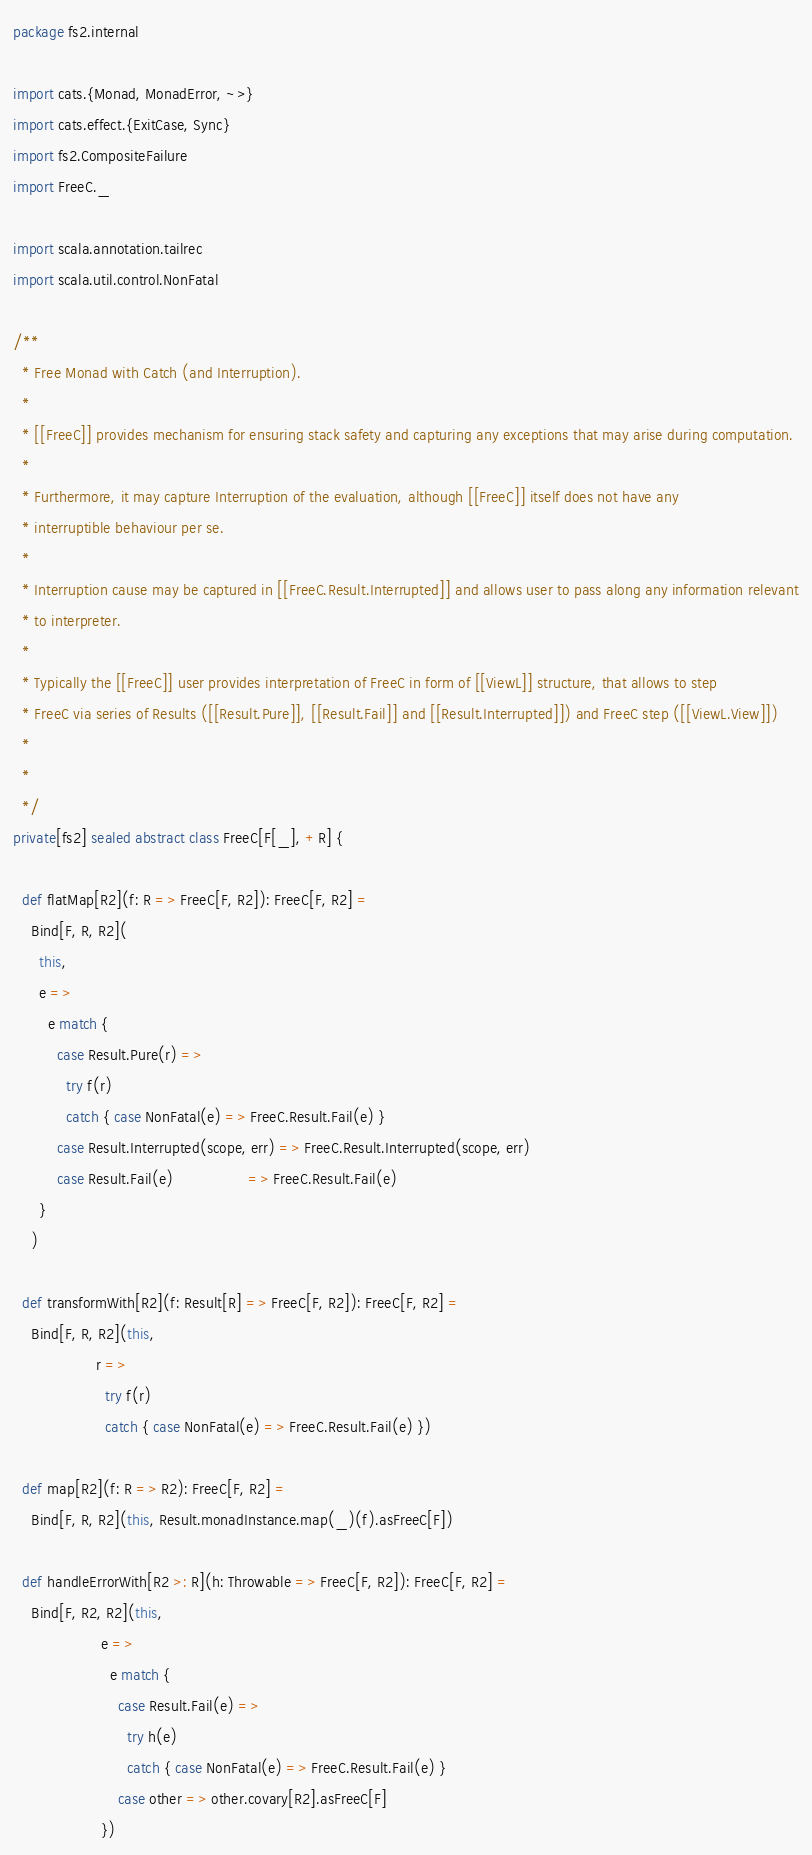<code> <loc_0><loc_0><loc_500><loc_500><_Scala_>package fs2.internal

import cats.{Monad, MonadError, ~>}
import cats.effect.{ExitCase, Sync}
import fs2.CompositeFailure
import FreeC._

import scala.annotation.tailrec
import scala.util.control.NonFatal

/**
  * Free Monad with Catch (and Interruption).
  *
  * [[FreeC]] provides mechanism for ensuring stack safety and capturing any exceptions that may arise during computation.
  *
  * Furthermore, it may capture Interruption of the evaluation, although [[FreeC]] itself does not have any
  * interruptible behaviour per se.
  *
  * Interruption cause may be captured in [[FreeC.Result.Interrupted]] and allows user to pass along any information relevant
  * to interpreter.
  *
  * Typically the [[FreeC]] user provides interpretation of FreeC in form of [[ViewL]] structure, that allows to step
  * FreeC via series of Results ([[Result.Pure]], [[Result.Fail]] and [[Result.Interrupted]]) and FreeC step ([[ViewL.View]])
  *
  *
  */
private[fs2] sealed abstract class FreeC[F[_], +R] {

  def flatMap[R2](f: R => FreeC[F, R2]): FreeC[F, R2] =
    Bind[F, R, R2](
      this,
      e =>
        e match {
          case Result.Pure(r) =>
            try f(r)
            catch { case NonFatal(e) => FreeC.Result.Fail(e) }
          case Result.Interrupted(scope, err) => FreeC.Result.Interrupted(scope, err)
          case Result.Fail(e)                 => FreeC.Result.Fail(e)
      }
    )

  def transformWith[R2](f: Result[R] => FreeC[F, R2]): FreeC[F, R2] =
    Bind[F, R, R2](this,
                   r =>
                     try f(r)
                     catch { case NonFatal(e) => FreeC.Result.Fail(e) })

  def map[R2](f: R => R2): FreeC[F, R2] =
    Bind[F, R, R2](this, Result.monadInstance.map(_)(f).asFreeC[F])

  def handleErrorWith[R2 >: R](h: Throwable => FreeC[F, R2]): FreeC[F, R2] =
    Bind[F, R2, R2](this,
                    e =>
                      e match {
                        case Result.Fail(e) =>
                          try h(e)
                          catch { case NonFatal(e) => FreeC.Result.Fail(e) }
                        case other => other.covary[R2].asFreeC[F]
                    })
</code> 